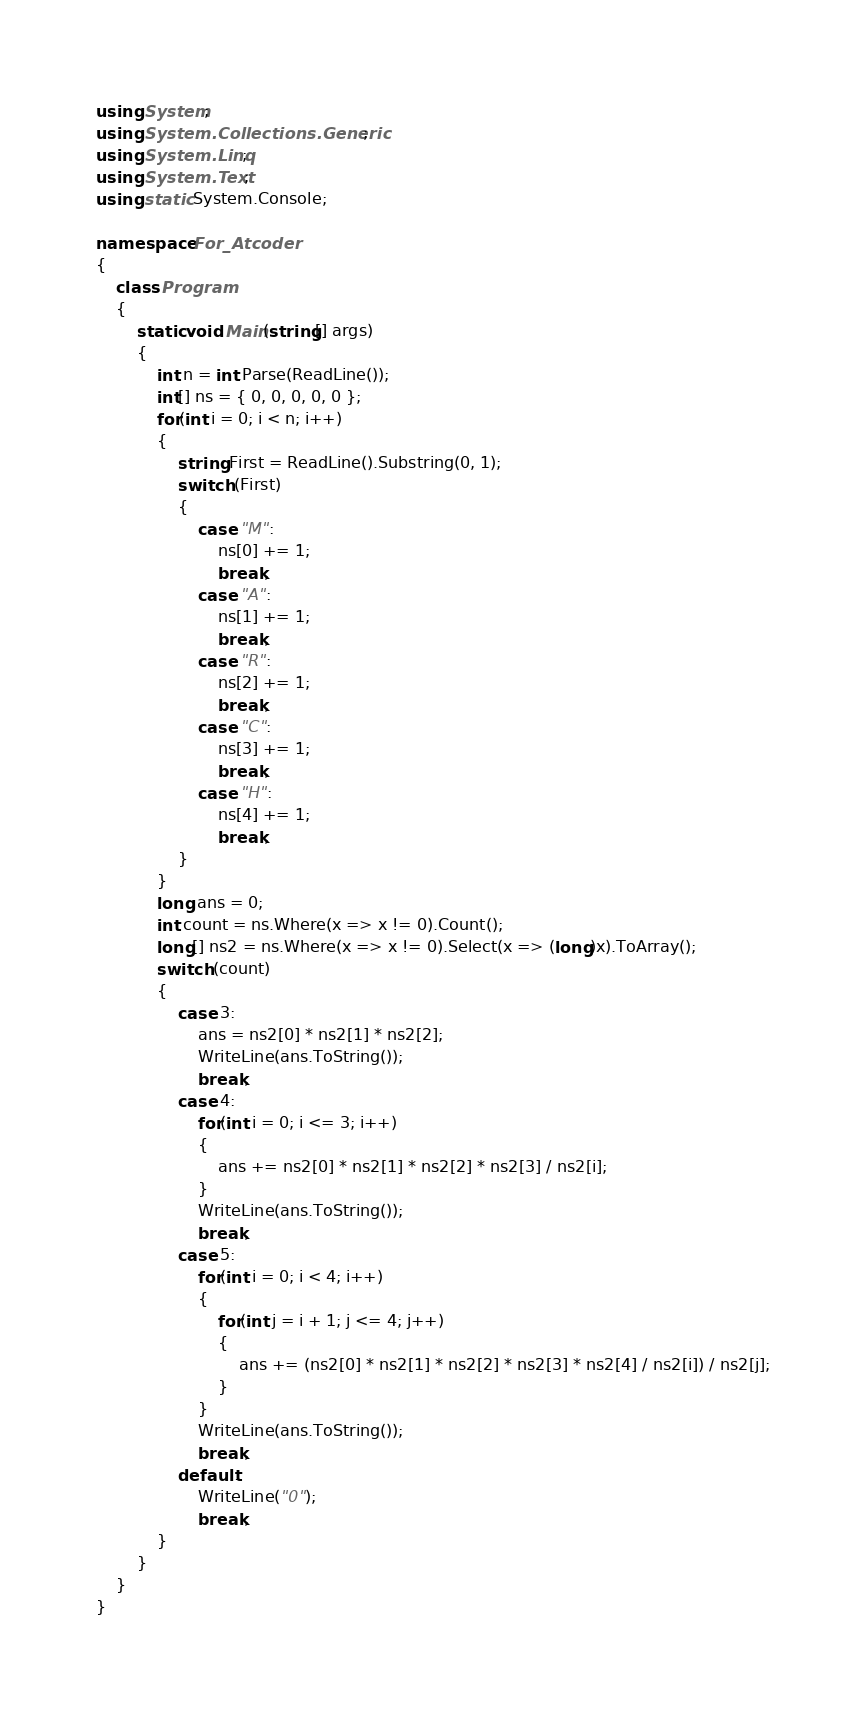<code> <loc_0><loc_0><loc_500><loc_500><_C#_>using System;
using System.Collections.Generic;
using System.Linq;
using System.Text;
using static System.Console;

namespace For_Atcoder
{
    class Program
    {
        static void Main(string[] args)
        {
            int n = int.Parse(ReadLine());
            int[] ns = { 0, 0, 0, 0, 0 };
            for(int i = 0; i < n; i++)
            {
                string First = ReadLine().Substring(0, 1);
                switch (First)
                {
                    case "M":
                        ns[0] += 1;
                        break;
                    case "A":
                        ns[1] += 1;
                        break;
                    case "R":
                        ns[2] += 1;
                        break;
                    case "C":
                        ns[3] += 1;
                        break;
                    case "H":
                        ns[4] += 1;
                        break;
                }
            }
            long ans = 0;
            int count = ns.Where(x => x != 0).Count();
            long[] ns2 = ns.Where(x => x != 0).Select(x => (long)x).ToArray();
            switch (count)
            {
                case 3:
                    ans = ns2[0] * ns2[1] * ns2[2];
                    WriteLine(ans.ToString());
                    break;
                case 4:
                    for(int i = 0; i <= 3; i++)
                    {
                        ans += ns2[0] * ns2[1] * ns2[2] * ns2[3] / ns2[i];
                    }
                    WriteLine(ans.ToString());
                    break;
                case 5:
                    for(int i = 0; i < 4; i++)
                    {
                        for(int j = i + 1; j <= 4; j++)
                        {
                            ans += (ns2[0] * ns2[1] * ns2[2] * ns2[3] * ns2[4] / ns2[i]) / ns2[j];
                        }
                    }
                    WriteLine(ans.ToString());
                    break;
                default:
                    WriteLine("0");
                    break;
            }
        }
    }
}</code> 